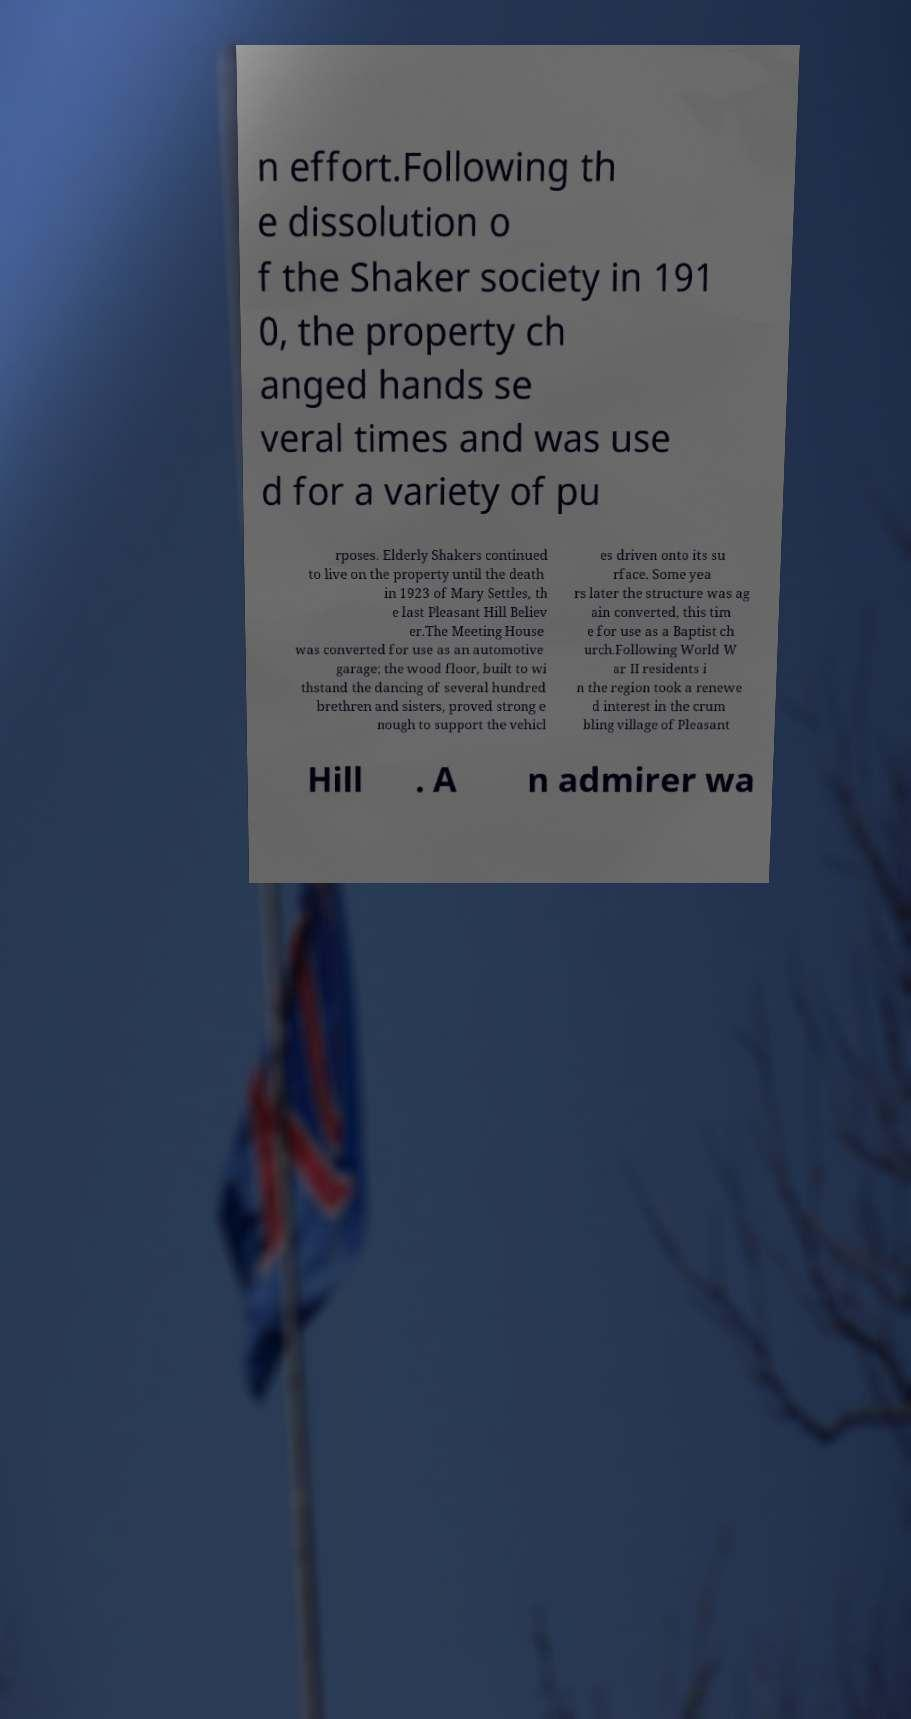Could you assist in decoding the text presented in this image and type it out clearly? n effort.Following th e dissolution o f the Shaker society in 191 0, the property ch anged hands se veral times and was use d for a variety of pu rposes. Elderly Shakers continued to live on the property until the death in 1923 of Mary Settles, th e last Pleasant Hill Believ er.The Meeting House was converted for use as an automotive garage; the wood floor, built to wi thstand the dancing of several hundred brethren and sisters, proved strong e nough to support the vehicl es driven onto its su rface. Some yea rs later the structure was ag ain converted, this tim e for use as a Baptist ch urch.Following World W ar II residents i n the region took a renewe d interest in the crum bling village of Pleasant Hill . A n admirer wa 